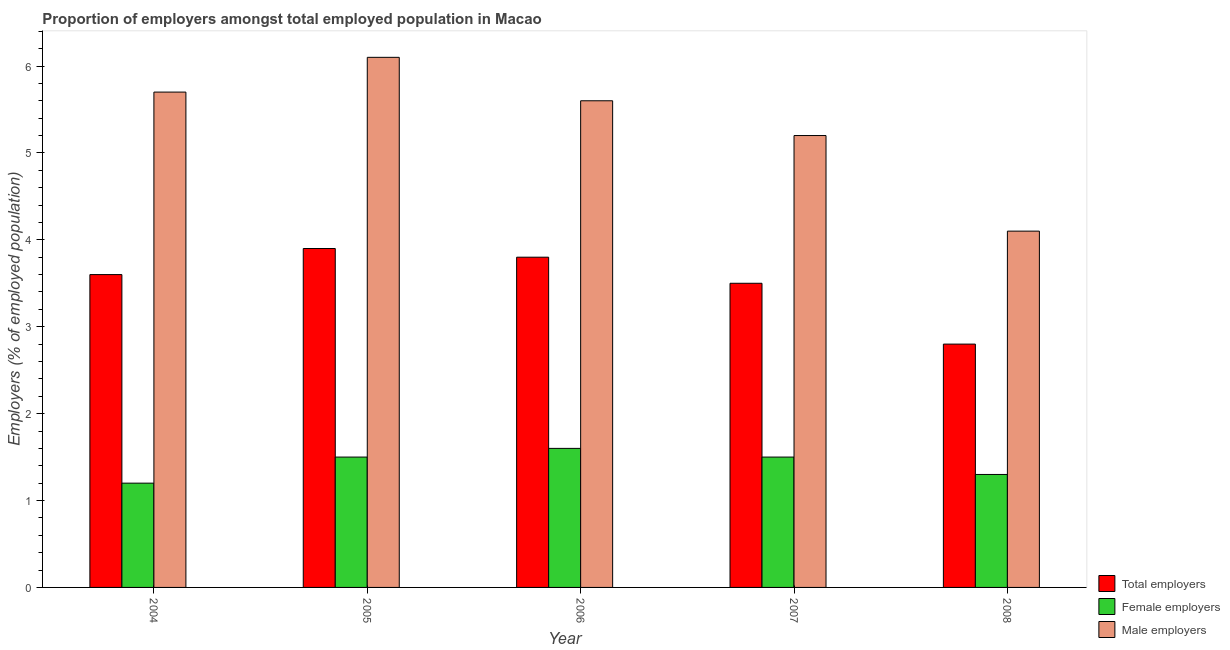Are the number of bars on each tick of the X-axis equal?
Your response must be concise. Yes. How many bars are there on the 3rd tick from the left?
Ensure brevity in your answer.  3. How many bars are there on the 4th tick from the right?
Ensure brevity in your answer.  3. In how many cases, is the number of bars for a given year not equal to the number of legend labels?
Offer a terse response. 0. What is the percentage of male employers in 2007?
Offer a terse response. 5.2. Across all years, what is the maximum percentage of total employers?
Offer a terse response. 3.9. Across all years, what is the minimum percentage of male employers?
Your answer should be compact. 4.1. What is the total percentage of female employers in the graph?
Ensure brevity in your answer.  7.1. What is the difference between the percentage of female employers in 2005 and that in 2006?
Keep it short and to the point. -0.1. What is the difference between the percentage of male employers in 2004 and the percentage of total employers in 2005?
Your answer should be compact. -0.4. What is the average percentage of male employers per year?
Provide a succinct answer. 5.34. In the year 2004, what is the difference between the percentage of male employers and percentage of female employers?
Offer a very short reply. 0. What is the ratio of the percentage of female employers in 2007 to that in 2008?
Ensure brevity in your answer.  1.15. Is the difference between the percentage of female employers in 2004 and 2006 greater than the difference between the percentage of male employers in 2004 and 2006?
Make the answer very short. No. What is the difference between the highest and the second highest percentage of total employers?
Provide a succinct answer. 0.1. What is the difference between the highest and the lowest percentage of female employers?
Your response must be concise. 0.4. Is the sum of the percentage of total employers in 2004 and 2005 greater than the maximum percentage of female employers across all years?
Ensure brevity in your answer.  Yes. What does the 1st bar from the left in 2004 represents?
Your answer should be compact. Total employers. What does the 3rd bar from the right in 2004 represents?
Your answer should be compact. Total employers. How many bars are there?
Provide a short and direct response. 15. How many years are there in the graph?
Provide a short and direct response. 5. Where does the legend appear in the graph?
Ensure brevity in your answer.  Bottom right. How many legend labels are there?
Keep it short and to the point. 3. What is the title of the graph?
Offer a very short reply. Proportion of employers amongst total employed population in Macao. What is the label or title of the Y-axis?
Ensure brevity in your answer.  Employers (% of employed population). What is the Employers (% of employed population) in Total employers in 2004?
Ensure brevity in your answer.  3.6. What is the Employers (% of employed population) in Female employers in 2004?
Your answer should be compact. 1.2. What is the Employers (% of employed population) of Male employers in 2004?
Make the answer very short. 5.7. What is the Employers (% of employed population) in Total employers in 2005?
Give a very brief answer. 3.9. What is the Employers (% of employed population) of Female employers in 2005?
Offer a very short reply. 1.5. What is the Employers (% of employed population) of Male employers in 2005?
Your answer should be compact. 6.1. What is the Employers (% of employed population) in Total employers in 2006?
Make the answer very short. 3.8. What is the Employers (% of employed population) in Female employers in 2006?
Your answer should be compact. 1.6. What is the Employers (% of employed population) of Male employers in 2006?
Your answer should be very brief. 5.6. What is the Employers (% of employed population) in Male employers in 2007?
Make the answer very short. 5.2. What is the Employers (% of employed population) of Total employers in 2008?
Offer a very short reply. 2.8. What is the Employers (% of employed population) in Female employers in 2008?
Give a very brief answer. 1.3. What is the Employers (% of employed population) of Male employers in 2008?
Provide a short and direct response. 4.1. Across all years, what is the maximum Employers (% of employed population) in Total employers?
Your answer should be very brief. 3.9. Across all years, what is the maximum Employers (% of employed population) of Female employers?
Give a very brief answer. 1.6. Across all years, what is the maximum Employers (% of employed population) in Male employers?
Provide a succinct answer. 6.1. Across all years, what is the minimum Employers (% of employed population) in Total employers?
Your answer should be very brief. 2.8. Across all years, what is the minimum Employers (% of employed population) of Female employers?
Provide a short and direct response. 1.2. Across all years, what is the minimum Employers (% of employed population) of Male employers?
Keep it short and to the point. 4.1. What is the total Employers (% of employed population) in Total employers in the graph?
Offer a terse response. 17.6. What is the total Employers (% of employed population) in Male employers in the graph?
Give a very brief answer. 26.7. What is the difference between the Employers (% of employed population) of Female employers in 2004 and that in 2005?
Provide a succinct answer. -0.3. What is the difference between the Employers (% of employed population) in Male employers in 2004 and that in 2005?
Your answer should be compact. -0.4. What is the difference between the Employers (% of employed population) in Total employers in 2004 and that in 2006?
Keep it short and to the point. -0.2. What is the difference between the Employers (% of employed population) of Male employers in 2004 and that in 2006?
Your answer should be very brief. 0.1. What is the difference between the Employers (% of employed population) in Total employers in 2004 and that in 2007?
Your answer should be very brief. 0.1. What is the difference between the Employers (% of employed population) of Female employers in 2004 and that in 2007?
Offer a terse response. -0.3. What is the difference between the Employers (% of employed population) of Female employers in 2004 and that in 2008?
Your response must be concise. -0.1. What is the difference between the Employers (% of employed population) in Male employers in 2004 and that in 2008?
Provide a short and direct response. 1.6. What is the difference between the Employers (% of employed population) of Female employers in 2005 and that in 2006?
Offer a very short reply. -0.1. What is the difference between the Employers (% of employed population) of Male employers in 2005 and that in 2006?
Ensure brevity in your answer.  0.5. What is the difference between the Employers (% of employed population) of Female employers in 2005 and that in 2007?
Provide a short and direct response. 0. What is the difference between the Employers (% of employed population) in Male employers in 2005 and that in 2007?
Make the answer very short. 0.9. What is the difference between the Employers (% of employed population) in Total employers in 2005 and that in 2008?
Offer a terse response. 1.1. What is the difference between the Employers (% of employed population) of Female employers in 2005 and that in 2008?
Give a very brief answer. 0.2. What is the difference between the Employers (% of employed population) in Male employers in 2005 and that in 2008?
Give a very brief answer. 2. What is the difference between the Employers (% of employed population) of Male employers in 2006 and that in 2007?
Provide a short and direct response. 0.4. What is the difference between the Employers (% of employed population) of Total employers in 2006 and that in 2008?
Your answer should be very brief. 1. What is the difference between the Employers (% of employed population) of Female employers in 2006 and that in 2008?
Provide a succinct answer. 0.3. What is the difference between the Employers (% of employed population) in Total employers in 2007 and that in 2008?
Keep it short and to the point. 0.7. What is the difference between the Employers (% of employed population) of Female employers in 2007 and that in 2008?
Offer a terse response. 0.2. What is the difference between the Employers (% of employed population) in Total employers in 2004 and the Employers (% of employed population) in Male employers in 2005?
Provide a short and direct response. -2.5. What is the difference between the Employers (% of employed population) of Total employers in 2004 and the Employers (% of employed population) of Female employers in 2006?
Your answer should be very brief. 2. What is the difference between the Employers (% of employed population) in Total employers in 2004 and the Employers (% of employed population) in Female employers in 2008?
Your answer should be very brief. 2.3. What is the difference between the Employers (% of employed population) of Total employers in 2004 and the Employers (% of employed population) of Male employers in 2008?
Your response must be concise. -0.5. What is the difference between the Employers (% of employed population) of Female employers in 2004 and the Employers (% of employed population) of Male employers in 2008?
Your response must be concise. -2.9. What is the difference between the Employers (% of employed population) in Total employers in 2005 and the Employers (% of employed population) in Female employers in 2006?
Your answer should be very brief. 2.3. What is the difference between the Employers (% of employed population) in Total employers in 2005 and the Employers (% of employed population) in Female employers in 2007?
Provide a succinct answer. 2.4. What is the difference between the Employers (% of employed population) of Total employers in 2005 and the Employers (% of employed population) of Male employers in 2007?
Provide a short and direct response. -1.3. What is the difference between the Employers (% of employed population) in Female employers in 2005 and the Employers (% of employed population) in Male employers in 2008?
Offer a very short reply. -2.6. What is the difference between the Employers (% of employed population) of Total employers in 2006 and the Employers (% of employed population) of Male employers in 2007?
Ensure brevity in your answer.  -1.4. What is the difference between the Employers (% of employed population) in Total employers in 2006 and the Employers (% of employed population) in Female employers in 2008?
Keep it short and to the point. 2.5. What is the difference between the Employers (% of employed population) of Total employers in 2006 and the Employers (% of employed population) of Male employers in 2008?
Provide a short and direct response. -0.3. What is the difference between the Employers (% of employed population) of Female employers in 2006 and the Employers (% of employed population) of Male employers in 2008?
Offer a terse response. -2.5. What is the average Employers (% of employed population) of Total employers per year?
Provide a succinct answer. 3.52. What is the average Employers (% of employed population) in Female employers per year?
Provide a short and direct response. 1.42. What is the average Employers (% of employed population) in Male employers per year?
Your answer should be very brief. 5.34. In the year 2004, what is the difference between the Employers (% of employed population) in Total employers and Employers (% of employed population) in Female employers?
Ensure brevity in your answer.  2.4. In the year 2005, what is the difference between the Employers (% of employed population) in Total employers and Employers (% of employed population) in Female employers?
Your response must be concise. 2.4. In the year 2005, what is the difference between the Employers (% of employed population) in Female employers and Employers (% of employed population) in Male employers?
Make the answer very short. -4.6. In the year 2006, what is the difference between the Employers (% of employed population) of Total employers and Employers (% of employed population) of Female employers?
Give a very brief answer. 2.2. In the year 2007, what is the difference between the Employers (% of employed population) of Female employers and Employers (% of employed population) of Male employers?
Ensure brevity in your answer.  -3.7. In the year 2008, what is the difference between the Employers (% of employed population) in Total employers and Employers (% of employed population) in Female employers?
Keep it short and to the point. 1.5. In the year 2008, what is the difference between the Employers (% of employed population) of Female employers and Employers (% of employed population) of Male employers?
Offer a very short reply. -2.8. What is the ratio of the Employers (% of employed population) in Total employers in 2004 to that in 2005?
Offer a very short reply. 0.92. What is the ratio of the Employers (% of employed population) in Male employers in 2004 to that in 2005?
Keep it short and to the point. 0.93. What is the ratio of the Employers (% of employed population) of Total employers in 2004 to that in 2006?
Keep it short and to the point. 0.95. What is the ratio of the Employers (% of employed population) in Male employers in 2004 to that in 2006?
Your answer should be very brief. 1.02. What is the ratio of the Employers (% of employed population) in Total employers in 2004 to that in 2007?
Keep it short and to the point. 1.03. What is the ratio of the Employers (% of employed population) of Female employers in 2004 to that in 2007?
Provide a short and direct response. 0.8. What is the ratio of the Employers (% of employed population) of Male employers in 2004 to that in 2007?
Offer a very short reply. 1.1. What is the ratio of the Employers (% of employed population) in Total employers in 2004 to that in 2008?
Provide a succinct answer. 1.29. What is the ratio of the Employers (% of employed population) of Male employers in 2004 to that in 2008?
Make the answer very short. 1.39. What is the ratio of the Employers (% of employed population) of Total employers in 2005 to that in 2006?
Make the answer very short. 1.03. What is the ratio of the Employers (% of employed population) of Female employers in 2005 to that in 2006?
Offer a terse response. 0.94. What is the ratio of the Employers (% of employed population) of Male employers in 2005 to that in 2006?
Give a very brief answer. 1.09. What is the ratio of the Employers (% of employed population) in Total employers in 2005 to that in 2007?
Offer a very short reply. 1.11. What is the ratio of the Employers (% of employed population) of Female employers in 2005 to that in 2007?
Your response must be concise. 1. What is the ratio of the Employers (% of employed population) in Male employers in 2005 to that in 2007?
Provide a short and direct response. 1.17. What is the ratio of the Employers (% of employed population) of Total employers in 2005 to that in 2008?
Provide a short and direct response. 1.39. What is the ratio of the Employers (% of employed population) in Female employers in 2005 to that in 2008?
Your answer should be very brief. 1.15. What is the ratio of the Employers (% of employed population) of Male employers in 2005 to that in 2008?
Make the answer very short. 1.49. What is the ratio of the Employers (% of employed population) in Total employers in 2006 to that in 2007?
Your answer should be very brief. 1.09. What is the ratio of the Employers (% of employed population) in Female employers in 2006 to that in 2007?
Your answer should be compact. 1.07. What is the ratio of the Employers (% of employed population) of Total employers in 2006 to that in 2008?
Provide a succinct answer. 1.36. What is the ratio of the Employers (% of employed population) of Female employers in 2006 to that in 2008?
Keep it short and to the point. 1.23. What is the ratio of the Employers (% of employed population) of Male employers in 2006 to that in 2008?
Provide a succinct answer. 1.37. What is the ratio of the Employers (% of employed population) of Female employers in 2007 to that in 2008?
Your response must be concise. 1.15. What is the ratio of the Employers (% of employed population) of Male employers in 2007 to that in 2008?
Provide a short and direct response. 1.27. What is the difference between the highest and the second highest Employers (% of employed population) of Female employers?
Keep it short and to the point. 0.1. What is the difference between the highest and the second highest Employers (% of employed population) of Male employers?
Give a very brief answer. 0.4. What is the difference between the highest and the lowest Employers (% of employed population) in Female employers?
Your answer should be compact. 0.4. What is the difference between the highest and the lowest Employers (% of employed population) of Male employers?
Offer a terse response. 2. 